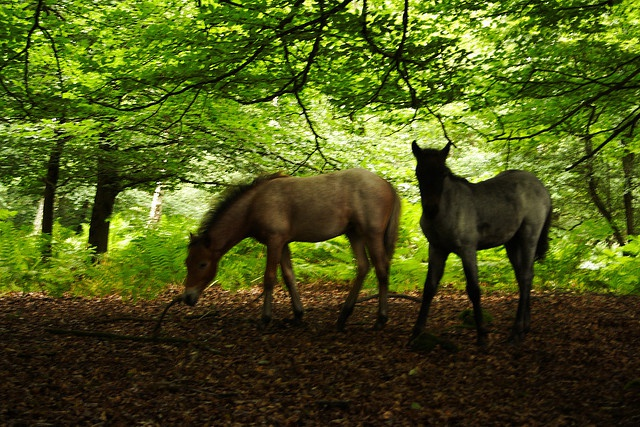Describe the objects in this image and their specific colors. I can see horse in darkgreen, black, and olive tones and horse in darkgreen, black, and olive tones in this image. 